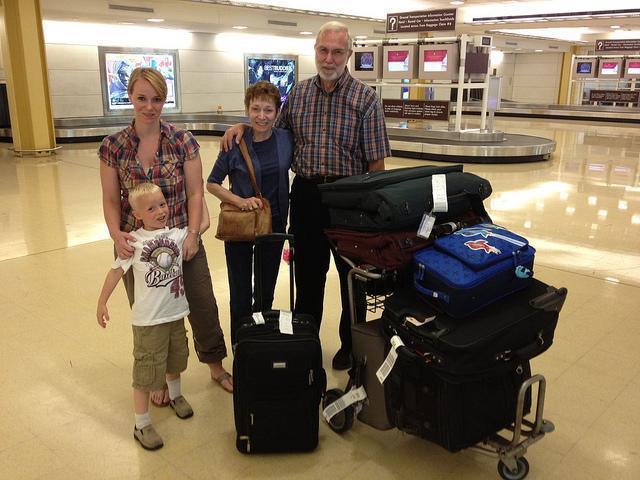What is this area for?
Answer the question by selecting the correct answer among the 4 following choices.
Options: Claiming baggage, boarding flight, waiting, security. Claiming baggage. 